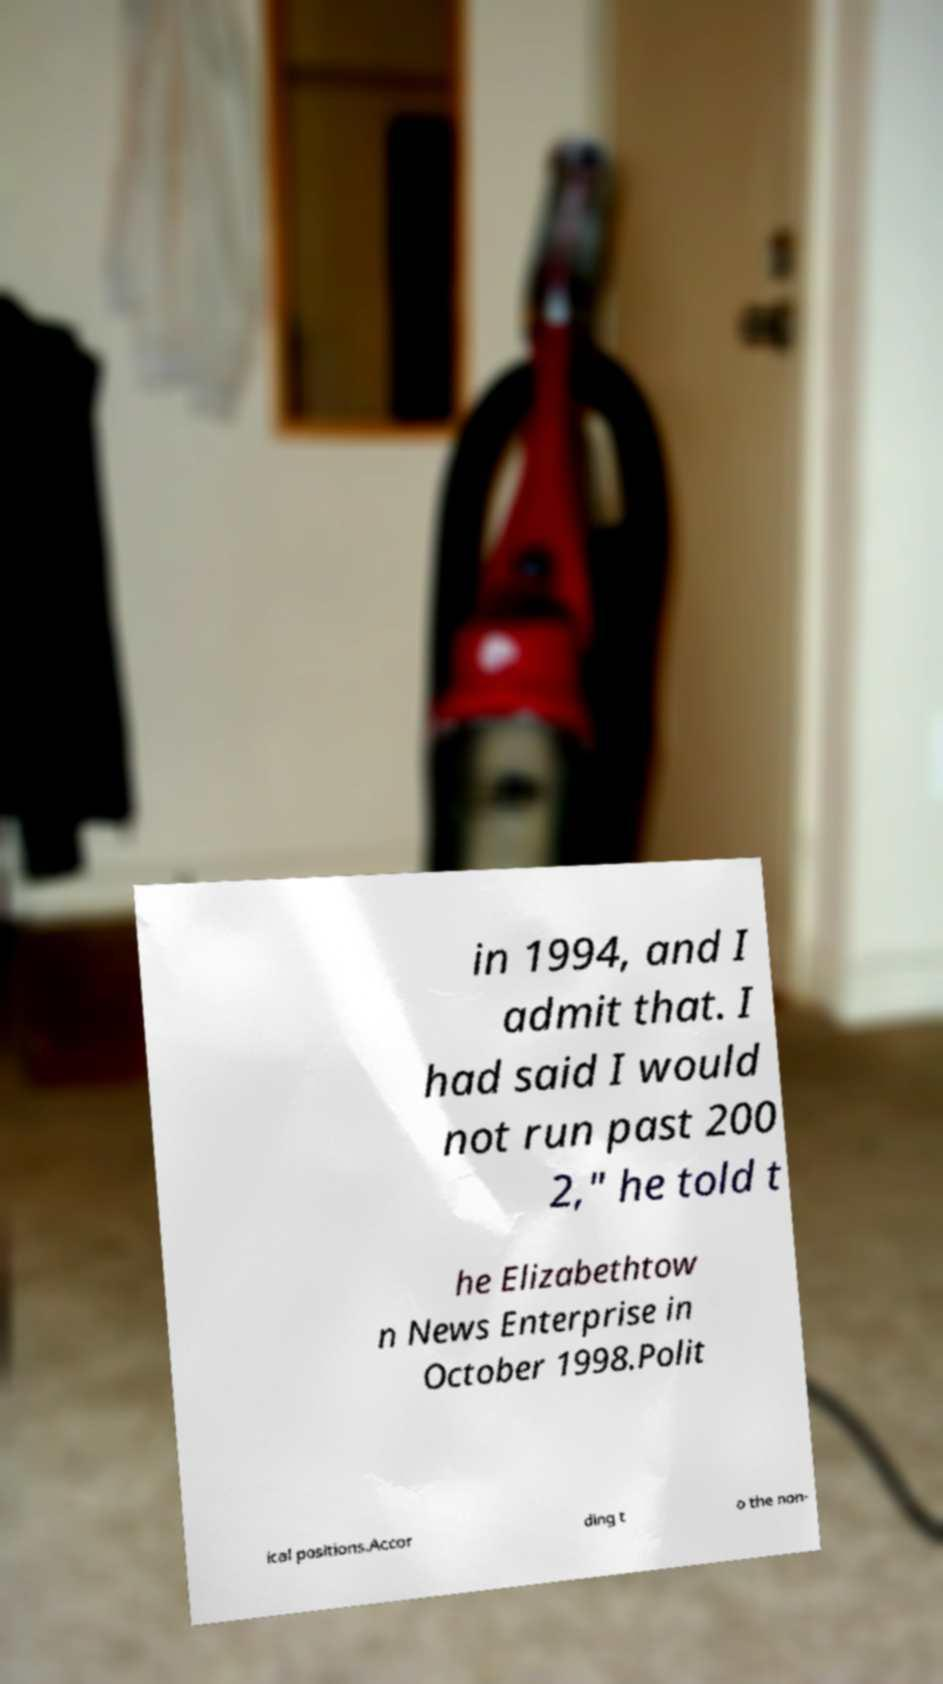Please read and relay the text visible in this image. What does it say? in 1994, and I admit that. I had said I would not run past 200 2," he told t he Elizabethtow n News Enterprise in October 1998.Polit ical positions.Accor ding t o the non- 